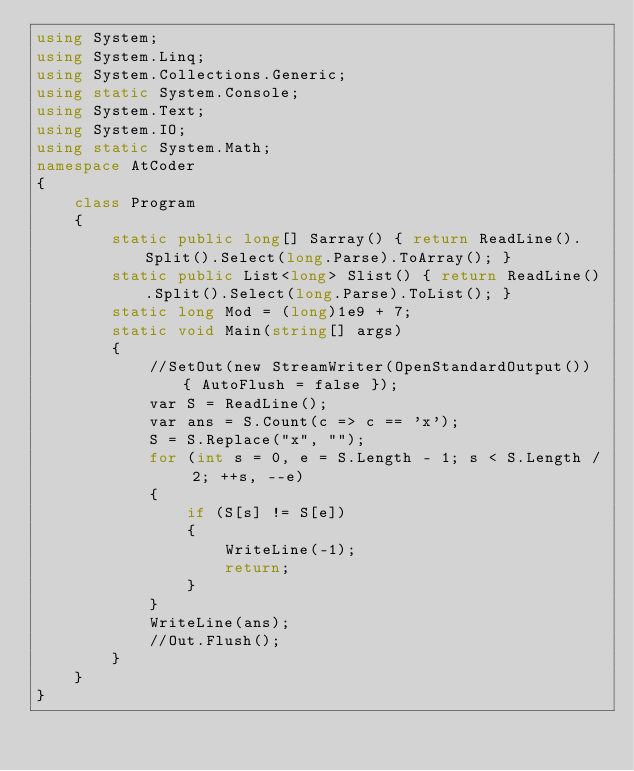<code> <loc_0><loc_0><loc_500><loc_500><_C#_>using System;
using System.Linq;
using System.Collections.Generic;
using static System.Console;
using System.Text;
using System.IO;
using static System.Math;
namespace AtCoder
{
    class Program
    {
        static public long[] Sarray() { return ReadLine().Split().Select(long.Parse).ToArray(); }
        static public List<long> Slist() { return ReadLine().Split().Select(long.Parse).ToList(); }
        static long Mod = (long)1e9 + 7;
        static void Main(string[] args)
        {
            //SetOut(new StreamWriter(OpenStandardOutput()) { AutoFlush = false });
            var S = ReadLine();
            var ans = S.Count(c => c == 'x');
            S = S.Replace("x", "");
            for (int s = 0, e = S.Length - 1; s < S.Length / 2; ++s, --e)
            {
                if (S[s] != S[e])
                {
                    WriteLine(-1);
                    return;
                }
            }
            WriteLine(ans);
            //Out.Flush();
        }
    }
}
</code> 